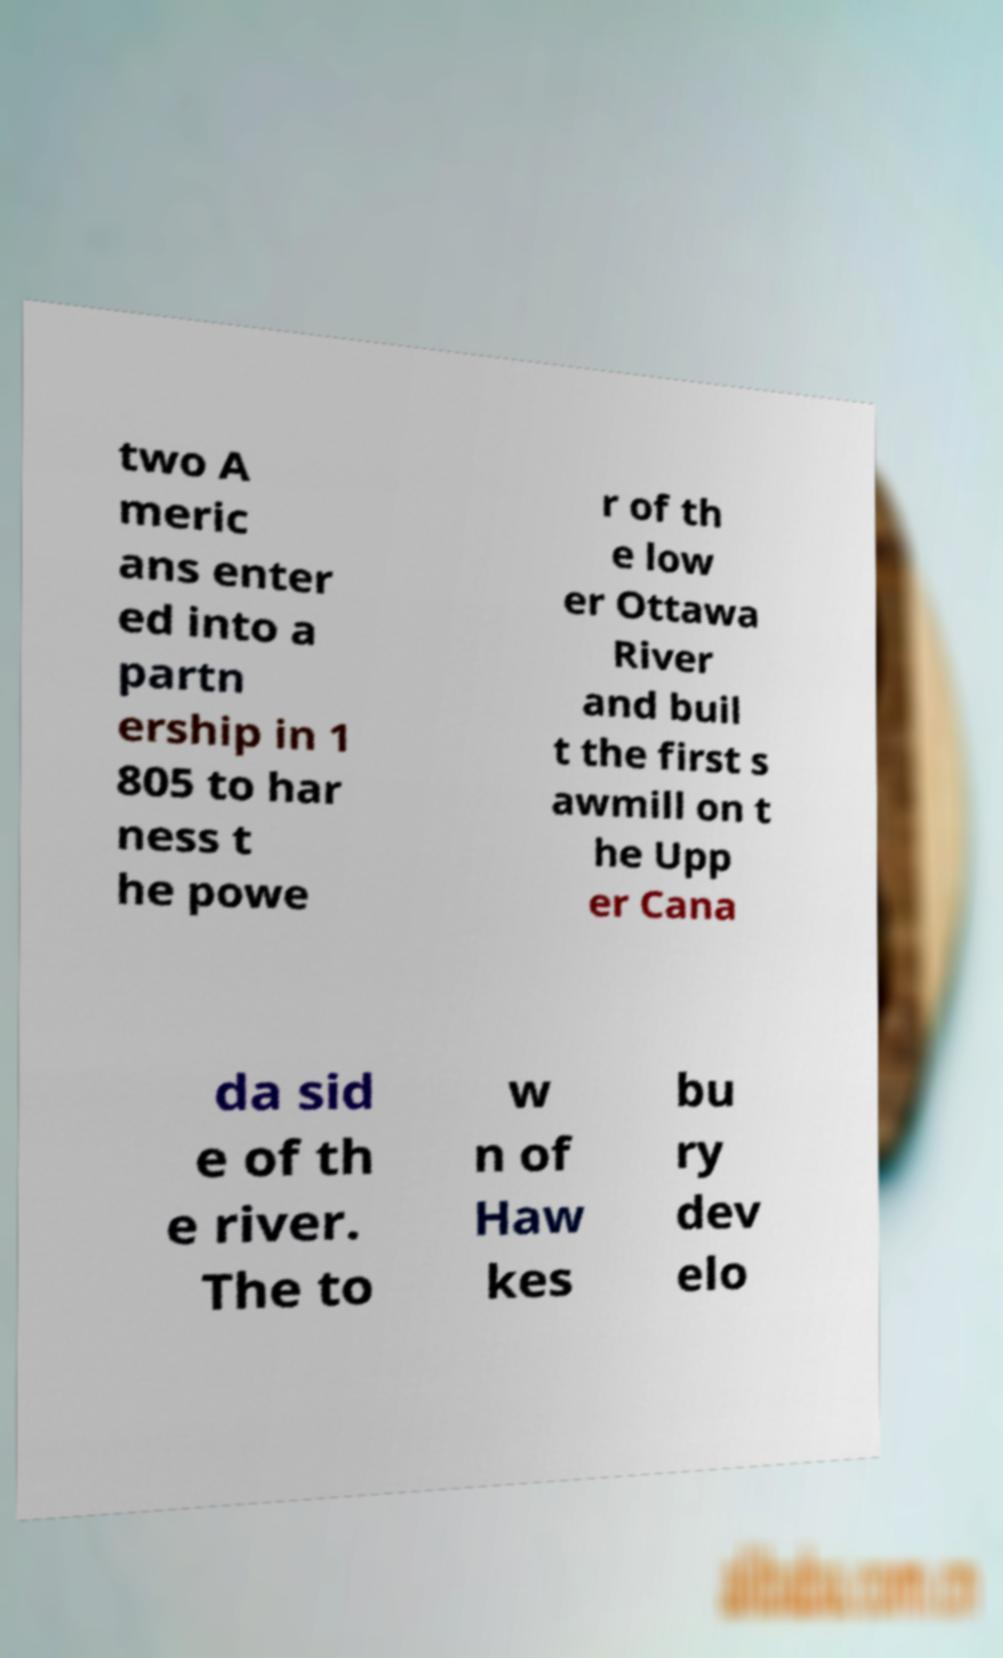Please identify and transcribe the text found in this image. two A meric ans enter ed into a partn ership in 1 805 to har ness t he powe r of th e low er Ottawa River and buil t the first s awmill on t he Upp er Cana da sid e of th e river. The to w n of Haw kes bu ry dev elo 